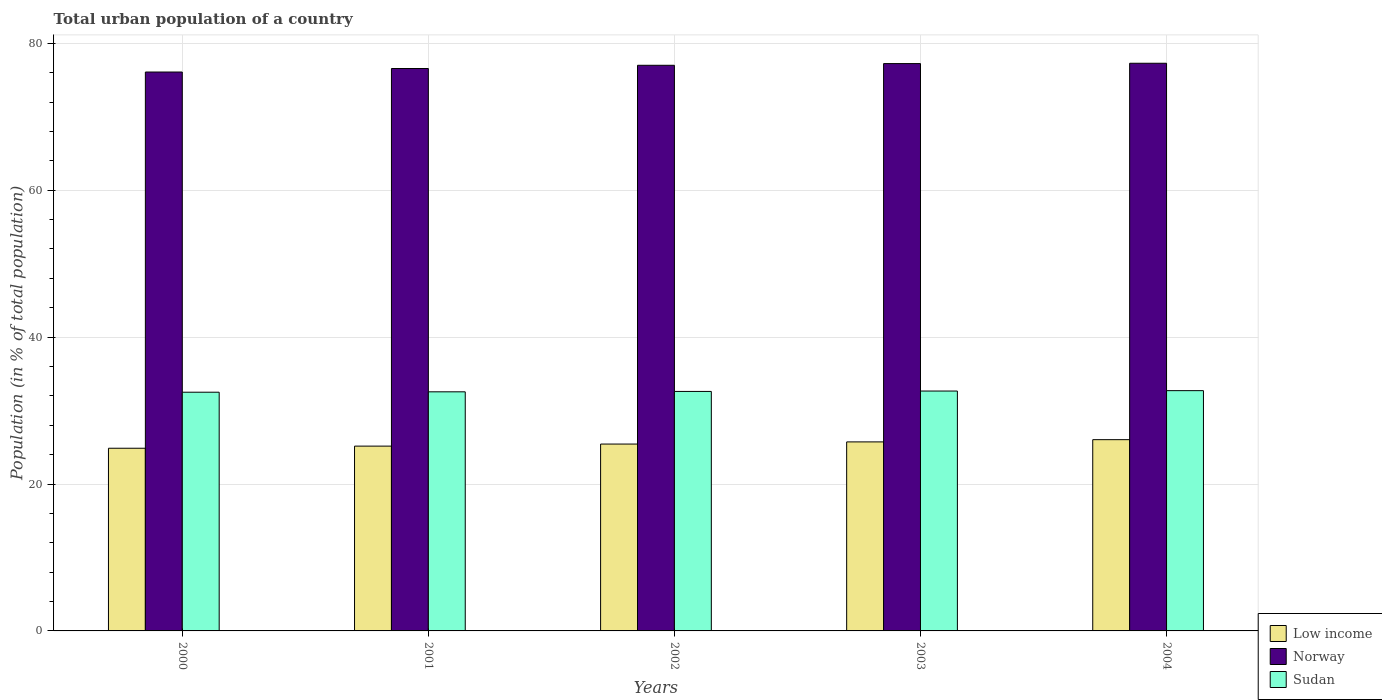Are the number of bars per tick equal to the number of legend labels?
Provide a short and direct response. Yes. What is the urban population in Sudan in 2002?
Provide a short and direct response. 32.6. Across all years, what is the maximum urban population in Sudan?
Give a very brief answer. 32.71. Across all years, what is the minimum urban population in Sudan?
Keep it short and to the point. 32.49. In which year was the urban population in Low income minimum?
Offer a very short reply. 2000. What is the total urban population in Low income in the graph?
Give a very brief answer. 127.23. What is the difference between the urban population in Low income in 2000 and that in 2002?
Provide a short and direct response. -0.57. What is the difference between the urban population in Sudan in 2003 and the urban population in Low income in 2001?
Offer a terse response. 7.5. What is the average urban population in Norway per year?
Ensure brevity in your answer.  76.83. In the year 2000, what is the difference between the urban population in Norway and urban population in Low income?
Provide a short and direct response. 51.21. In how many years, is the urban population in Norway greater than 40 %?
Make the answer very short. 5. What is the ratio of the urban population in Sudan in 2000 to that in 2003?
Provide a succinct answer. 1. Is the difference between the urban population in Norway in 2002 and 2004 greater than the difference between the urban population in Low income in 2002 and 2004?
Offer a very short reply. Yes. What is the difference between the highest and the second highest urban population in Low income?
Your response must be concise. 0.3. What is the difference between the highest and the lowest urban population in Low income?
Give a very brief answer. 1.17. How many bars are there?
Provide a short and direct response. 15. Are all the bars in the graph horizontal?
Provide a short and direct response. No. How many years are there in the graph?
Offer a very short reply. 5. Does the graph contain any zero values?
Provide a succinct answer. No. Does the graph contain grids?
Give a very brief answer. Yes. How are the legend labels stacked?
Ensure brevity in your answer.  Vertical. What is the title of the graph?
Your answer should be very brief. Total urban population of a country. Does "Iceland" appear as one of the legend labels in the graph?
Keep it short and to the point. No. What is the label or title of the X-axis?
Make the answer very short. Years. What is the label or title of the Y-axis?
Keep it short and to the point. Population (in % of total population). What is the Population (in % of total population) of Low income in 2000?
Your answer should be very brief. 24.87. What is the Population (in % of total population) of Norway in 2000?
Give a very brief answer. 76.08. What is the Population (in % of total population) in Sudan in 2000?
Your answer should be very brief. 32.49. What is the Population (in % of total population) of Low income in 2001?
Your response must be concise. 25.16. What is the Population (in % of total population) of Norway in 2001?
Offer a terse response. 76.56. What is the Population (in % of total population) of Sudan in 2001?
Make the answer very short. 32.55. What is the Population (in % of total population) of Low income in 2002?
Ensure brevity in your answer.  25.44. What is the Population (in % of total population) in Norway in 2002?
Your answer should be compact. 77. What is the Population (in % of total population) in Sudan in 2002?
Provide a succinct answer. 32.6. What is the Population (in % of total population) in Low income in 2003?
Offer a very short reply. 25.73. What is the Population (in % of total population) in Norway in 2003?
Your answer should be very brief. 77.23. What is the Population (in % of total population) of Sudan in 2003?
Make the answer very short. 32.65. What is the Population (in % of total population) in Low income in 2004?
Give a very brief answer. 26.03. What is the Population (in % of total population) in Norway in 2004?
Keep it short and to the point. 77.28. What is the Population (in % of total population) of Sudan in 2004?
Provide a short and direct response. 32.71. Across all years, what is the maximum Population (in % of total population) in Low income?
Make the answer very short. 26.03. Across all years, what is the maximum Population (in % of total population) of Norway?
Offer a very short reply. 77.28. Across all years, what is the maximum Population (in % of total population) of Sudan?
Offer a terse response. 32.71. Across all years, what is the minimum Population (in % of total population) of Low income?
Your answer should be very brief. 24.87. Across all years, what is the minimum Population (in % of total population) in Norway?
Give a very brief answer. 76.08. Across all years, what is the minimum Population (in % of total population) in Sudan?
Offer a terse response. 32.49. What is the total Population (in % of total population) of Low income in the graph?
Offer a terse response. 127.23. What is the total Population (in % of total population) of Norway in the graph?
Ensure brevity in your answer.  384.15. What is the total Population (in % of total population) of Sudan in the graph?
Your response must be concise. 163. What is the difference between the Population (in % of total population) in Low income in 2000 and that in 2001?
Provide a succinct answer. -0.29. What is the difference between the Population (in % of total population) in Norway in 2000 and that in 2001?
Provide a short and direct response. -0.48. What is the difference between the Population (in % of total population) of Sudan in 2000 and that in 2001?
Your answer should be very brief. -0.05. What is the difference between the Population (in % of total population) of Low income in 2000 and that in 2002?
Give a very brief answer. -0.57. What is the difference between the Population (in % of total population) of Norway in 2000 and that in 2002?
Make the answer very short. -0.92. What is the difference between the Population (in % of total population) of Sudan in 2000 and that in 2002?
Provide a succinct answer. -0.11. What is the difference between the Population (in % of total population) in Low income in 2000 and that in 2003?
Provide a short and direct response. -0.86. What is the difference between the Population (in % of total population) in Norway in 2000 and that in 2003?
Offer a terse response. -1.15. What is the difference between the Population (in % of total population) of Sudan in 2000 and that in 2003?
Offer a very short reply. -0.16. What is the difference between the Population (in % of total population) of Low income in 2000 and that in 2004?
Offer a terse response. -1.17. What is the difference between the Population (in % of total population) of Norway in 2000 and that in 2004?
Your answer should be very brief. -1.19. What is the difference between the Population (in % of total population) in Sudan in 2000 and that in 2004?
Give a very brief answer. -0.21. What is the difference between the Population (in % of total population) of Low income in 2001 and that in 2002?
Make the answer very short. -0.28. What is the difference between the Population (in % of total population) of Norway in 2001 and that in 2002?
Your response must be concise. -0.44. What is the difference between the Population (in % of total population) of Sudan in 2001 and that in 2002?
Keep it short and to the point. -0.05. What is the difference between the Population (in % of total population) of Low income in 2001 and that in 2003?
Your answer should be very brief. -0.58. What is the difference between the Population (in % of total population) in Norway in 2001 and that in 2003?
Provide a short and direct response. -0.67. What is the difference between the Population (in % of total population) of Sudan in 2001 and that in 2003?
Make the answer very short. -0.11. What is the difference between the Population (in % of total population) in Low income in 2001 and that in 2004?
Ensure brevity in your answer.  -0.88. What is the difference between the Population (in % of total population) of Norway in 2001 and that in 2004?
Give a very brief answer. -0.71. What is the difference between the Population (in % of total population) in Sudan in 2001 and that in 2004?
Give a very brief answer. -0.16. What is the difference between the Population (in % of total population) of Low income in 2002 and that in 2003?
Offer a very short reply. -0.29. What is the difference between the Population (in % of total population) in Norway in 2002 and that in 2003?
Your answer should be compact. -0.23. What is the difference between the Population (in % of total population) in Sudan in 2002 and that in 2003?
Your answer should be very brief. -0.05. What is the difference between the Population (in % of total population) in Low income in 2002 and that in 2004?
Your response must be concise. -0.6. What is the difference between the Population (in % of total population) of Norway in 2002 and that in 2004?
Offer a terse response. -0.28. What is the difference between the Population (in % of total population) in Sudan in 2002 and that in 2004?
Offer a terse response. -0.11. What is the difference between the Population (in % of total population) in Low income in 2003 and that in 2004?
Your response must be concise. -0.3. What is the difference between the Population (in % of total population) of Norway in 2003 and that in 2004?
Make the answer very short. -0.04. What is the difference between the Population (in % of total population) of Sudan in 2003 and that in 2004?
Make the answer very short. -0.05. What is the difference between the Population (in % of total population) in Low income in 2000 and the Population (in % of total population) in Norway in 2001?
Your response must be concise. -51.69. What is the difference between the Population (in % of total population) in Low income in 2000 and the Population (in % of total population) in Sudan in 2001?
Your response must be concise. -7.68. What is the difference between the Population (in % of total population) of Norway in 2000 and the Population (in % of total population) of Sudan in 2001?
Give a very brief answer. 43.53. What is the difference between the Population (in % of total population) in Low income in 2000 and the Population (in % of total population) in Norway in 2002?
Offer a very short reply. -52.13. What is the difference between the Population (in % of total population) in Low income in 2000 and the Population (in % of total population) in Sudan in 2002?
Provide a succinct answer. -7.73. What is the difference between the Population (in % of total population) of Norway in 2000 and the Population (in % of total population) of Sudan in 2002?
Ensure brevity in your answer.  43.48. What is the difference between the Population (in % of total population) in Low income in 2000 and the Population (in % of total population) in Norway in 2003?
Offer a very short reply. -52.36. What is the difference between the Population (in % of total population) of Low income in 2000 and the Population (in % of total population) of Sudan in 2003?
Provide a succinct answer. -7.79. What is the difference between the Population (in % of total population) of Norway in 2000 and the Population (in % of total population) of Sudan in 2003?
Your answer should be compact. 43.43. What is the difference between the Population (in % of total population) of Low income in 2000 and the Population (in % of total population) of Norway in 2004?
Make the answer very short. -52.41. What is the difference between the Population (in % of total population) of Low income in 2000 and the Population (in % of total population) of Sudan in 2004?
Your response must be concise. -7.84. What is the difference between the Population (in % of total population) in Norway in 2000 and the Population (in % of total population) in Sudan in 2004?
Your response must be concise. 43.37. What is the difference between the Population (in % of total population) in Low income in 2001 and the Population (in % of total population) in Norway in 2002?
Keep it short and to the point. -51.84. What is the difference between the Population (in % of total population) of Low income in 2001 and the Population (in % of total population) of Sudan in 2002?
Make the answer very short. -7.44. What is the difference between the Population (in % of total population) in Norway in 2001 and the Population (in % of total population) in Sudan in 2002?
Ensure brevity in your answer.  43.96. What is the difference between the Population (in % of total population) in Low income in 2001 and the Population (in % of total population) in Norway in 2003?
Provide a short and direct response. -52.07. What is the difference between the Population (in % of total population) of Low income in 2001 and the Population (in % of total population) of Sudan in 2003?
Ensure brevity in your answer.  -7.5. What is the difference between the Population (in % of total population) in Norway in 2001 and the Population (in % of total population) in Sudan in 2003?
Your answer should be very brief. 43.91. What is the difference between the Population (in % of total population) in Low income in 2001 and the Population (in % of total population) in Norway in 2004?
Ensure brevity in your answer.  -52.12. What is the difference between the Population (in % of total population) in Low income in 2001 and the Population (in % of total population) in Sudan in 2004?
Your response must be concise. -7.55. What is the difference between the Population (in % of total population) in Norway in 2001 and the Population (in % of total population) in Sudan in 2004?
Make the answer very short. 43.85. What is the difference between the Population (in % of total population) of Low income in 2002 and the Population (in % of total population) of Norway in 2003?
Offer a terse response. -51.79. What is the difference between the Population (in % of total population) of Low income in 2002 and the Population (in % of total population) of Sudan in 2003?
Give a very brief answer. -7.22. What is the difference between the Population (in % of total population) in Norway in 2002 and the Population (in % of total population) in Sudan in 2003?
Your answer should be compact. 44.34. What is the difference between the Population (in % of total population) of Low income in 2002 and the Population (in % of total population) of Norway in 2004?
Keep it short and to the point. -51.84. What is the difference between the Population (in % of total population) of Low income in 2002 and the Population (in % of total population) of Sudan in 2004?
Give a very brief answer. -7.27. What is the difference between the Population (in % of total population) of Norway in 2002 and the Population (in % of total population) of Sudan in 2004?
Provide a succinct answer. 44.29. What is the difference between the Population (in % of total population) in Low income in 2003 and the Population (in % of total population) in Norway in 2004?
Offer a very short reply. -51.54. What is the difference between the Population (in % of total population) in Low income in 2003 and the Population (in % of total population) in Sudan in 2004?
Your answer should be compact. -6.98. What is the difference between the Population (in % of total population) in Norway in 2003 and the Population (in % of total population) in Sudan in 2004?
Provide a succinct answer. 44.52. What is the average Population (in % of total population) of Low income per year?
Provide a succinct answer. 25.45. What is the average Population (in % of total population) in Norway per year?
Make the answer very short. 76.83. What is the average Population (in % of total population) of Sudan per year?
Provide a succinct answer. 32.6. In the year 2000, what is the difference between the Population (in % of total population) of Low income and Population (in % of total population) of Norway?
Keep it short and to the point. -51.21. In the year 2000, what is the difference between the Population (in % of total population) of Low income and Population (in % of total population) of Sudan?
Offer a very short reply. -7.63. In the year 2000, what is the difference between the Population (in % of total population) in Norway and Population (in % of total population) in Sudan?
Keep it short and to the point. 43.59. In the year 2001, what is the difference between the Population (in % of total population) of Low income and Population (in % of total population) of Norway?
Make the answer very short. -51.4. In the year 2001, what is the difference between the Population (in % of total population) in Low income and Population (in % of total population) in Sudan?
Offer a terse response. -7.39. In the year 2001, what is the difference between the Population (in % of total population) of Norway and Population (in % of total population) of Sudan?
Make the answer very short. 44.01. In the year 2002, what is the difference between the Population (in % of total population) in Low income and Population (in % of total population) in Norway?
Offer a terse response. -51.56. In the year 2002, what is the difference between the Population (in % of total population) in Low income and Population (in % of total population) in Sudan?
Your answer should be compact. -7.16. In the year 2002, what is the difference between the Population (in % of total population) in Norway and Population (in % of total population) in Sudan?
Your response must be concise. 44.4. In the year 2003, what is the difference between the Population (in % of total population) in Low income and Population (in % of total population) in Norway?
Your answer should be compact. -51.5. In the year 2003, what is the difference between the Population (in % of total population) of Low income and Population (in % of total population) of Sudan?
Make the answer very short. -6.92. In the year 2003, what is the difference between the Population (in % of total population) of Norway and Population (in % of total population) of Sudan?
Give a very brief answer. 44.58. In the year 2004, what is the difference between the Population (in % of total population) of Low income and Population (in % of total population) of Norway?
Your response must be concise. -51.24. In the year 2004, what is the difference between the Population (in % of total population) in Low income and Population (in % of total population) in Sudan?
Your response must be concise. -6.67. In the year 2004, what is the difference between the Population (in % of total population) in Norway and Population (in % of total population) in Sudan?
Offer a very short reply. 44.57. What is the ratio of the Population (in % of total population) of Sudan in 2000 to that in 2001?
Make the answer very short. 1. What is the ratio of the Population (in % of total population) in Low income in 2000 to that in 2002?
Offer a terse response. 0.98. What is the ratio of the Population (in % of total population) in Norway in 2000 to that in 2002?
Give a very brief answer. 0.99. What is the ratio of the Population (in % of total population) in Sudan in 2000 to that in 2002?
Offer a terse response. 1. What is the ratio of the Population (in % of total population) in Low income in 2000 to that in 2003?
Ensure brevity in your answer.  0.97. What is the ratio of the Population (in % of total population) of Norway in 2000 to that in 2003?
Offer a terse response. 0.99. What is the ratio of the Population (in % of total population) in Sudan in 2000 to that in 2003?
Make the answer very short. 1. What is the ratio of the Population (in % of total population) in Low income in 2000 to that in 2004?
Ensure brevity in your answer.  0.96. What is the ratio of the Population (in % of total population) of Norway in 2000 to that in 2004?
Your answer should be compact. 0.98. What is the ratio of the Population (in % of total population) in Low income in 2001 to that in 2002?
Keep it short and to the point. 0.99. What is the ratio of the Population (in % of total population) in Low income in 2001 to that in 2003?
Your response must be concise. 0.98. What is the ratio of the Population (in % of total population) in Norway in 2001 to that in 2003?
Provide a short and direct response. 0.99. What is the ratio of the Population (in % of total population) in Low income in 2001 to that in 2004?
Your answer should be compact. 0.97. What is the ratio of the Population (in % of total population) of Low income in 2002 to that in 2003?
Offer a terse response. 0.99. What is the ratio of the Population (in % of total population) in Low income in 2002 to that in 2004?
Keep it short and to the point. 0.98. What is the ratio of the Population (in % of total population) of Norway in 2002 to that in 2004?
Make the answer very short. 1. What is the ratio of the Population (in % of total population) in Sudan in 2002 to that in 2004?
Provide a short and direct response. 1. What is the ratio of the Population (in % of total population) in Low income in 2003 to that in 2004?
Give a very brief answer. 0.99. What is the ratio of the Population (in % of total population) of Norway in 2003 to that in 2004?
Provide a short and direct response. 1. What is the ratio of the Population (in % of total population) in Sudan in 2003 to that in 2004?
Offer a very short reply. 1. What is the difference between the highest and the second highest Population (in % of total population) of Low income?
Your answer should be very brief. 0.3. What is the difference between the highest and the second highest Population (in % of total population) of Norway?
Make the answer very short. 0.04. What is the difference between the highest and the second highest Population (in % of total population) of Sudan?
Offer a terse response. 0.05. What is the difference between the highest and the lowest Population (in % of total population) in Low income?
Ensure brevity in your answer.  1.17. What is the difference between the highest and the lowest Population (in % of total population) of Norway?
Provide a short and direct response. 1.19. What is the difference between the highest and the lowest Population (in % of total population) of Sudan?
Make the answer very short. 0.21. 